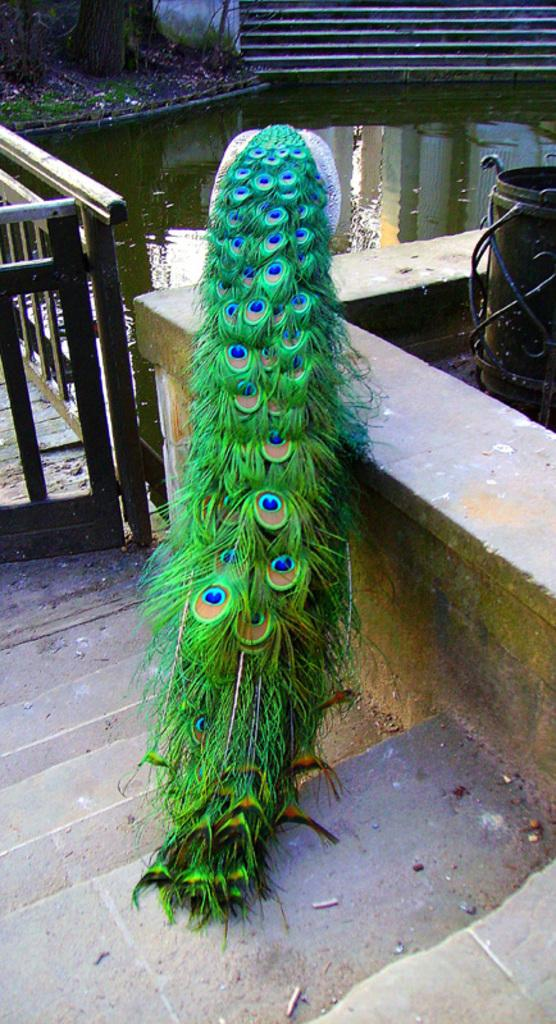What type of birds can be seen in the image? There is a peacock and a quail in the image. What can be seen in the background of the image? There are stairs visible in the background of the image. What is the terrain like in the image? There is water and grass in the image. What type of hat is the girl wearing in the image? There is no girl present in the image, so it is not possible to determine what type of hat she might be wearing. 